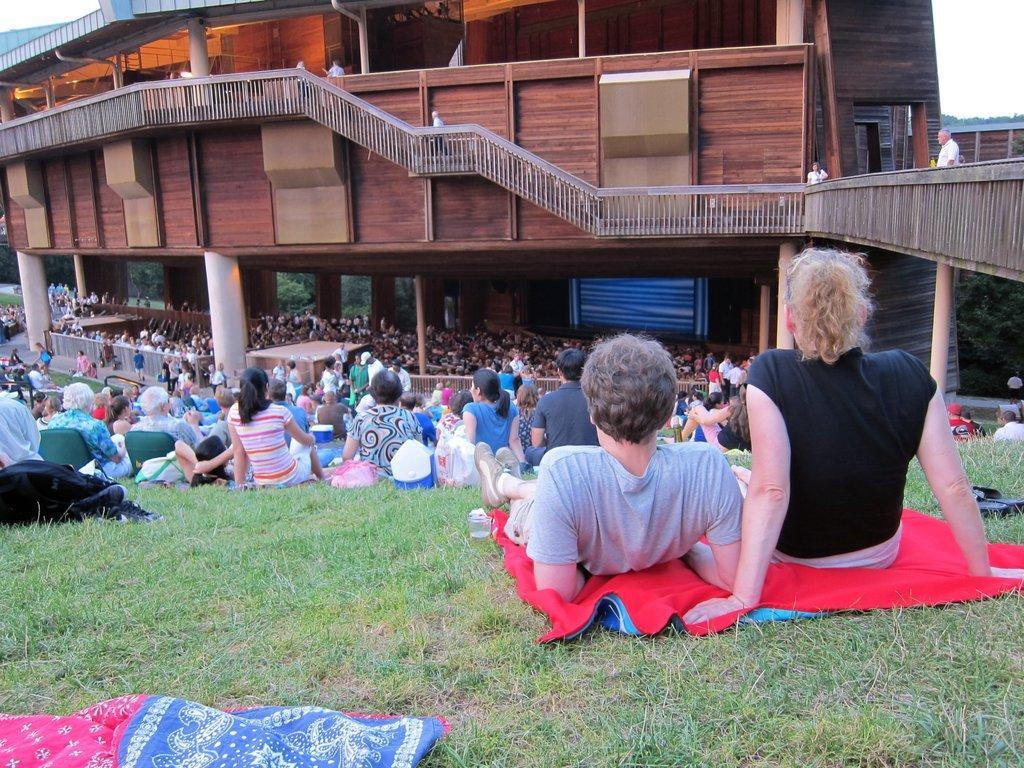Please provide a concise description of this image. In this picture we can observe some people sitting and laying on the ground. There is some grass on the ground. We can observe a pink and blue color cloth on the left side. There is a brown color building and a railing here. There were men and women in this picture. In the background there is a sky. 